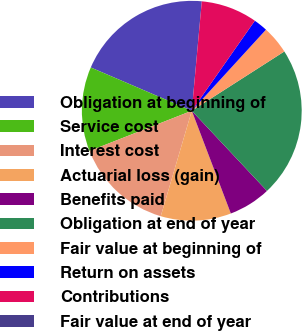Convert chart. <chart><loc_0><loc_0><loc_500><loc_500><pie_chart><fcel>Obligation at beginning of<fcel>Service cost<fcel>Interest cost<fcel>Actuarial loss (gain)<fcel>Benefits paid<fcel>Obligation at end of year<fcel>Fair value at beginning of<fcel>Return on assets<fcel>Contributions<fcel>Fair value at end of year<nl><fcel>20.01%<fcel>12.41%<fcel>14.48%<fcel>10.34%<fcel>6.21%<fcel>22.08%<fcel>4.14%<fcel>2.07%<fcel>8.27%<fcel>0.0%<nl></chart> 